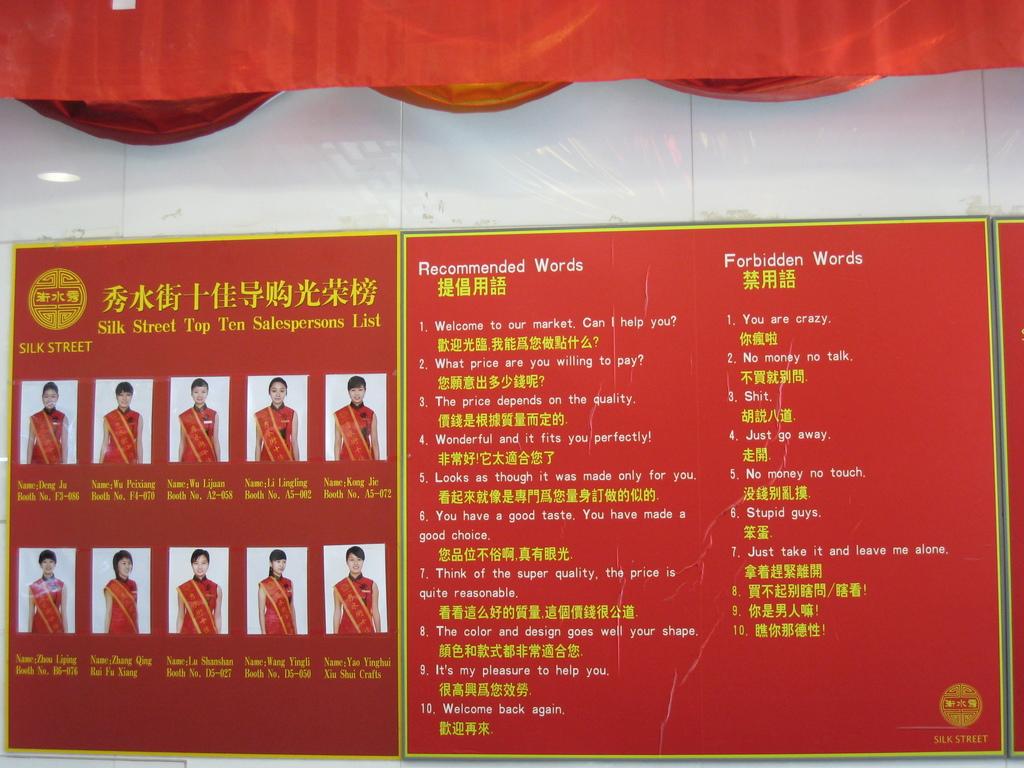What language is the poster written in?
Ensure brevity in your answer.  Chinese. 